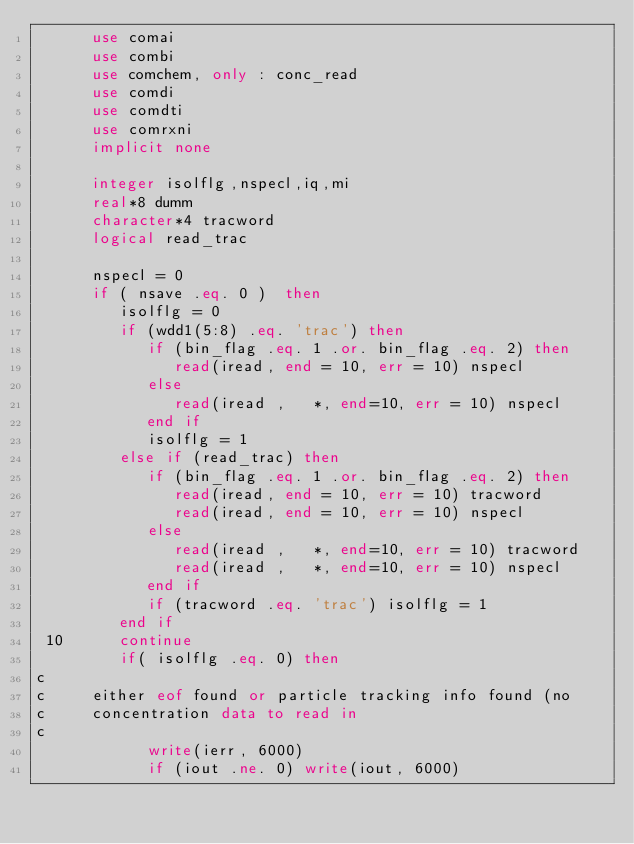Convert code to text. <code><loc_0><loc_0><loc_500><loc_500><_FORTRAN_>      use comai
      use combi
      use comchem, only : conc_read
      use comdi
      use comdti
      use comrxni
      implicit none

      integer isolflg,nspecl,iq,mi
      real*8 dumm
      character*4 tracword
      logical read_trac

      nspecl = 0
      if ( nsave .eq. 0 )  then
         isolflg = 0
         if (wdd1(5:8) .eq. 'trac') then
            if (bin_flag .eq. 1 .or. bin_flag .eq. 2) then
               read(iread, end = 10, err = 10) nspecl
            else
               read(iread ,   *, end=10, err = 10) nspecl
            end if
            isolflg = 1
         else if (read_trac) then
            if (bin_flag .eq. 1 .or. bin_flag .eq. 2) then
               read(iread, end = 10, err = 10) tracword
               read(iread, end = 10, err = 10) nspecl
            else
               read(iread ,   *, end=10, err = 10) tracword
               read(iread ,   *, end=10, err = 10) nspecl
            end if
            if (tracword .eq. 'trac') isolflg = 1
         end if
 10      continue
         if( isolflg .eq. 0) then
c     
c     either eof found or particle tracking info found (no
c     concentration data to read in
c     
            write(ierr, 6000)
            if (iout .ne. 0) write(iout, 6000)</code> 